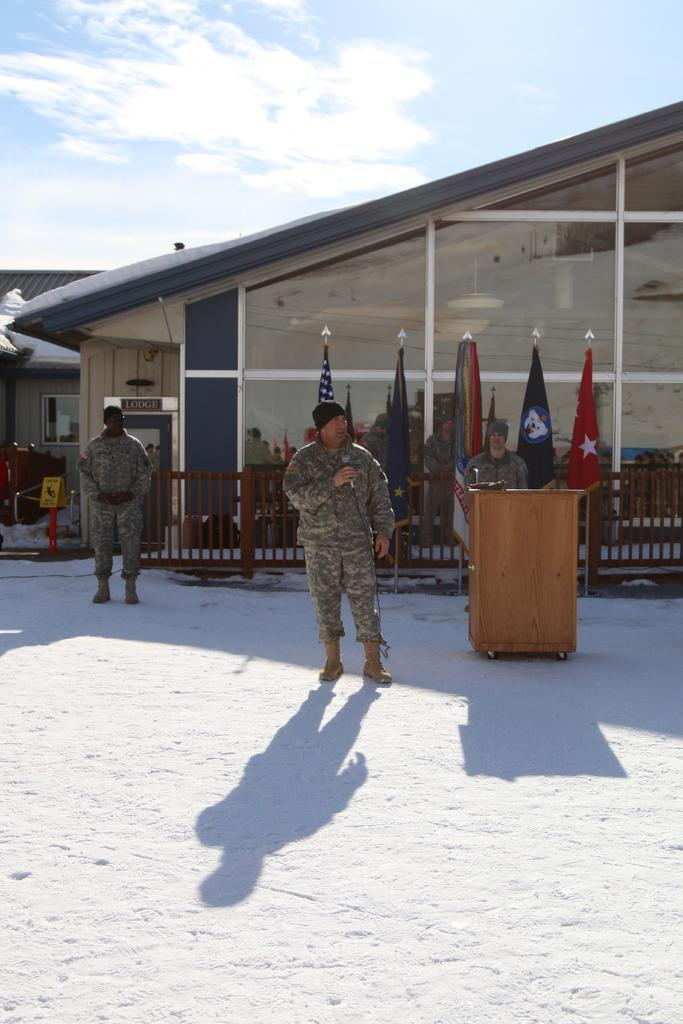How many people are in the image? There are people in the image, but the exact number is not specified. What can be seen in the image besides people? There are flags, a fence, boards, glass, sheds, and a podium visible in the image. What is the background of the image? The sky is visible in the background of the image, with clouds present. What type of structure is the podium? The podium is a raised platform for speakers or presenters. What type of fruit is hanging from the fence in the image? There is no fruit hanging from the fence in the image. Can you tell me how many tents are set up near the sheds in the image? There is no mention of tents in the image; only sheds are present. 